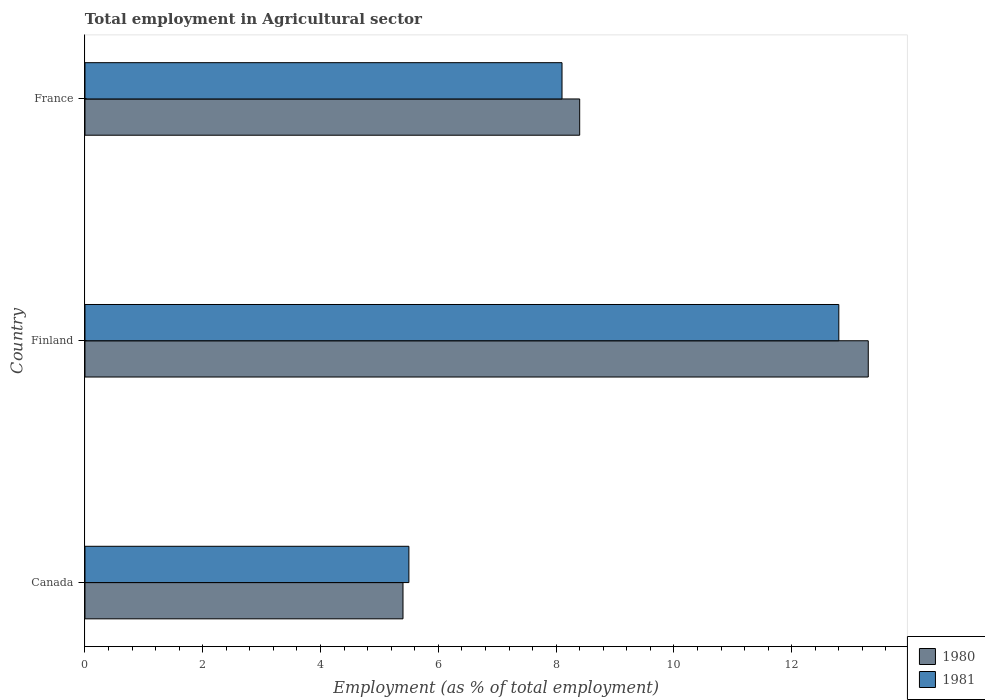Are the number of bars per tick equal to the number of legend labels?
Provide a succinct answer. Yes. In how many cases, is the number of bars for a given country not equal to the number of legend labels?
Give a very brief answer. 0. What is the employment in agricultural sector in 1981 in France?
Ensure brevity in your answer.  8.1. Across all countries, what is the maximum employment in agricultural sector in 1981?
Offer a very short reply. 12.8. In which country was the employment in agricultural sector in 1981 maximum?
Provide a short and direct response. Finland. In which country was the employment in agricultural sector in 1981 minimum?
Ensure brevity in your answer.  Canada. What is the total employment in agricultural sector in 1981 in the graph?
Make the answer very short. 26.4. What is the difference between the employment in agricultural sector in 1980 in Canada and that in Finland?
Your answer should be very brief. -7.9. What is the difference between the employment in agricultural sector in 1981 in Finland and the employment in agricultural sector in 1980 in France?
Provide a succinct answer. 4.4. What is the average employment in agricultural sector in 1981 per country?
Your answer should be compact. 8.8. What is the difference between the employment in agricultural sector in 1980 and employment in agricultural sector in 1981 in France?
Give a very brief answer. 0.3. In how many countries, is the employment in agricultural sector in 1980 greater than 13.2 %?
Offer a very short reply. 1. What is the ratio of the employment in agricultural sector in 1981 in Finland to that in France?
Make the answer very short. 1.58. What is the difference between the highest and the second highest employment in agricultural sector in 1980?
Provide a short and direct response. 4.9. What is the difference between the highest and the lowest employment in agricultural sector in 1980?
Ensure brevity in your answer.  7.9. In how many countries, is the employment in agricultural sector in 1981 greater than the average employment in agricultural sector in 1981 taken over all countries?
Keep it short and to the point. 1. What does the 2nd bar from the top in Canada represents?
Keep it short and to the point. 1980. How many bars are there?
Keep it short and to the point. 6. Are all the bars in the graph horizontal?
Provide a short and direct response. Yes. How many countries are there in the graph?
Your answer should be very brief. 3. What is the difference between two consecutive major ticks on the X-axis?
Keep it short and to the point. 2. Does the graph contain any zero values?
Provide a succinct answer. No. Does the graph contain grids?
Your response must be concise. No. How many legend labels are there?
Offer a terse response. 2. How are the legend labels stacked?
Ensure brevity in your answer.  Vertical. What is the title of the graph?
Make the answer very short. Total employment in Agricultural sector. Does "1995" appear as one of the legend labels in the graph?
Offer a terse response. No. What is the label or title of the X-axis?
Offer a terse response. Employment (as % of total employment). What is the Employment (as % of total employment) in 1980 in Canada?
Make the answer very short. 5.4. What is the Employment (as % of total employment) of 1981 in Canada?
Offer a very short reply. 5.5. What is the Employment (as % of total employment) of 1980 in Finland?
Keep it short and to the point. 13.3. What is the Employment (as % of total employment) in 1981 in Finland?
Give a very brief answer. 12.8. What is the Employment (as % of total employment) of 1980 in France?
Provide a short and direct response. 8.4. What is the Employment (as % of total employment) in 1981 in France?
Your response must be concise. 8.1. Across all countries, what is the maximum Employment (as % of total employment) in 1980?
Offer a terse response. 13.3. Across all countries, what is the maximum Employment (as % of total employment) in 1981?
Your answer should be compact. 12.8. Across all countries, what is the minimum Employment (as % of total employment) in 1980?
Make the answer very short. 5.4. What is the total Employment (as % of total employment) of 1980 in the graph?
Offer a very short reply. 27.1. What is the total Employment (as % of total employment) in 1981 in the graph?
Your answer should be very brief. 26.4. What is the difference between the Employment (as % of total employment) of 1980 in Canada and the Employment (as % of total employment) of 1981 in Finland?
Your answer should be compact. -7.4. What is the difference between the Employment (as % of total employment) in 1980 in Finland and the Employment (as % of total employment) in 1981 in France?
Keep it short and to the point. 5.2. What is the average Employment (as % of total employment) in 1980 per country?
Provide a succinct answer. 9.03. What is the difference between the Employment (as % of total employment) in 1980 and Employment (as % of total employment) in 1981 in Canada?
Make the answer very short. -0.1. What is the difference between the Employment (as % of total employment) in 1980 and Employment (as % of total employment) in 1981 in Finland?
Your answer should be very brief. 0.5. What is the difference between the Employment (as % of total employment) of 1980 and Employment (as % of total employment) of 1981 in France?
Offer a very short reply. 0.3. What is the ratio of the Employment (as % of total employment) of 1980 in Canada to that in Finland?
Ensure brevity in your answer.  0.41. What is the ratio of the Employment (as % of total employment) of 1981 in Canada to that in Finland?
Your response must be concise. 0.43. What is the ratio of the Employment (as % of total employment) of 1980 in Canada to that in France?
Your response must be concise. 0.64. What is the ratio of the Employment (as % of total employment) in 1981 in Canada to that in France?
Your answer should be very brief. 0.68. What is the ratio of the Employment (as % of total employment) of 1980 in Finland to that in France?
Give a very brief answer. 1.58. What is the ratio of the Employment (as % of total employment) in 1981 in Finland to that in France?
Offer a very short reply. 1.58. What is the difference between the highest and the second highest Employment (as % of total employment) in 1980?
Ensure brevity in your answer.  4.9. What is the difference between the highest and the lowest Employment (as % of total employment) in 1981?
Your answer should be very brief. 7.3. 